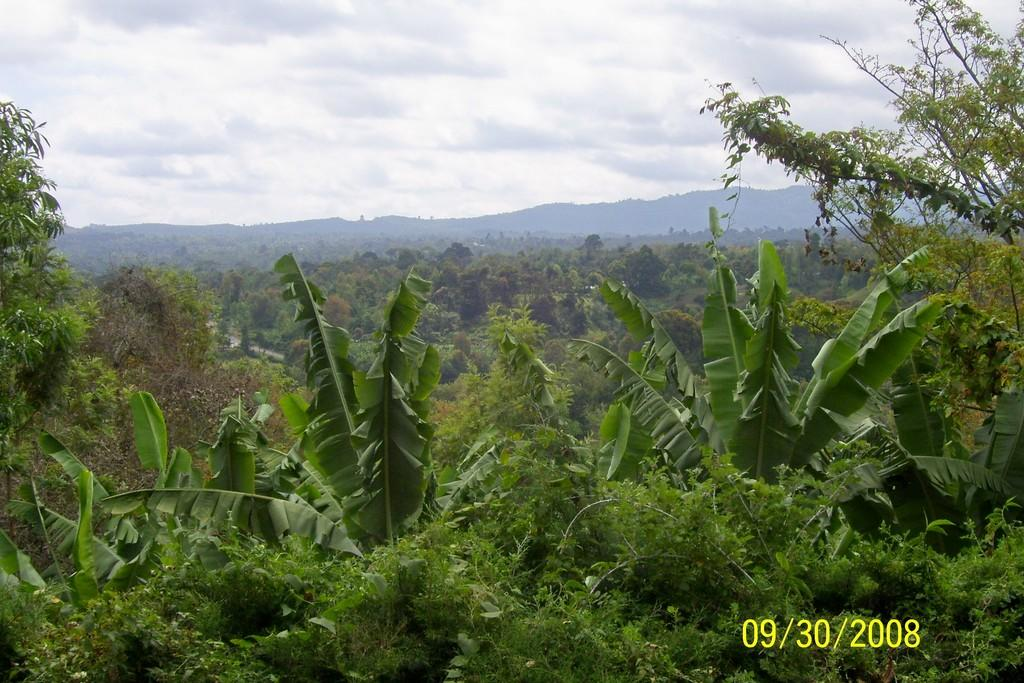What is the main feature of the image? The main feature of the image is the many trees. What can be seen in the background of the image? The sky and hills are visible in the background of the image. What is the condition of the sky in the image? The sky appears to be cloudy in the image. Is there any additional information provided in the image? Yes, there is a watermark in the bottom right side of the image, which represents a date. How many girls are playing with a clam in the image? There are no girls or clams present in the image; it features trees, a cloudy sky, and hills in the background. 